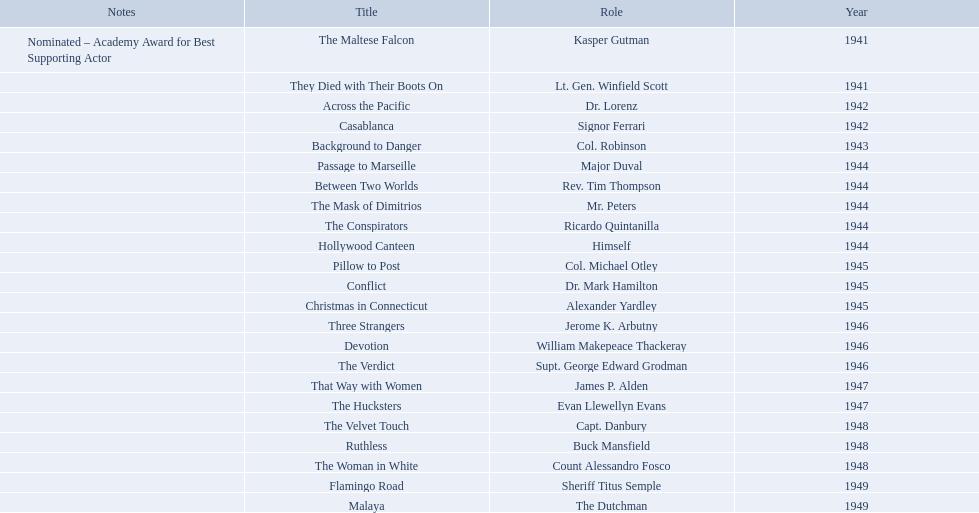What are all of the movies sydney greenstreet acted in? The Maltese Falcon, They Died with Their Boots On, Across the Pacific, Casablanca, Background to Danger, Passage to Marseille, Between Two Worlds, The Mask of Dimitrios, The Conspirators, Hollywood Canteen, Pillow to Post, Conflict, Christmas in Connecticut, Three Strangers, Devotion, The Verdict, That Way with Women, The Hucksters, The Velvet Touch, Ruthless, The Woman in White, Flamingo Road, Malaya. What are all of the title notes? Nominated – Academy Award for Best Supporting Actor. Which film was the award for? The Maltese Falcon. 